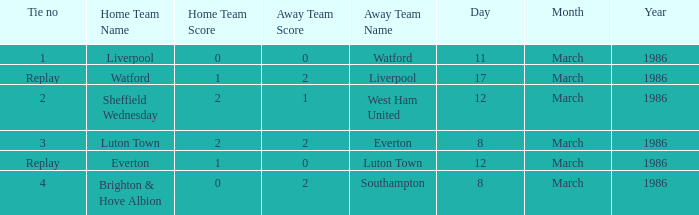What tie happened with Southampton? 4.0. 